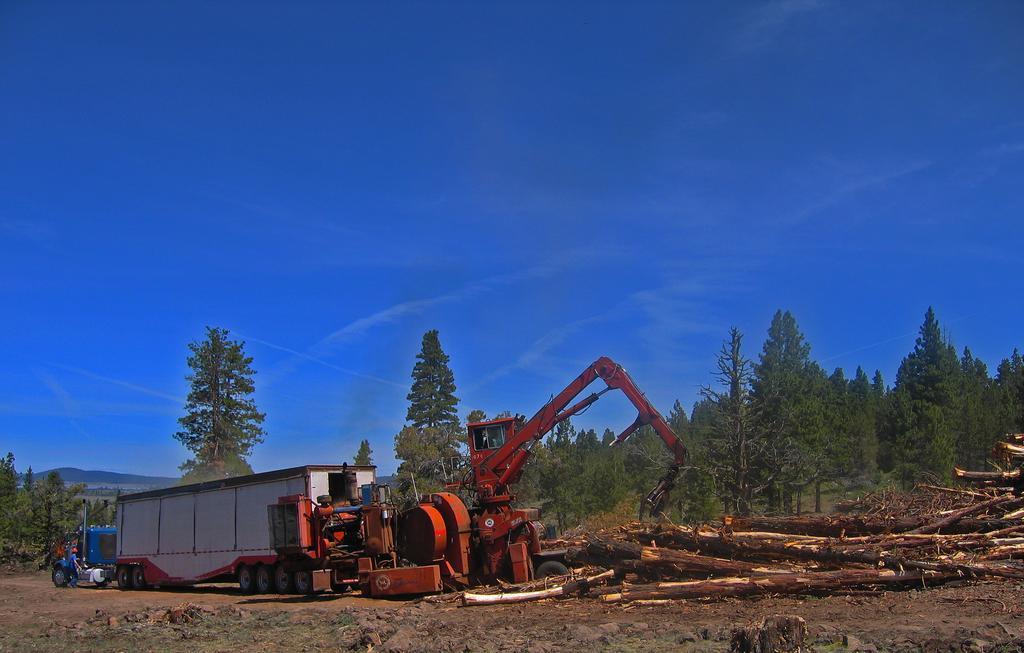How would you summarize this image in a sentence or two? Here we can see a excavator,container,vehicles and few persons on the ground. In the background we can see trees,mountains and clouds in the sky. On the right there are wooden logs on the ground. 